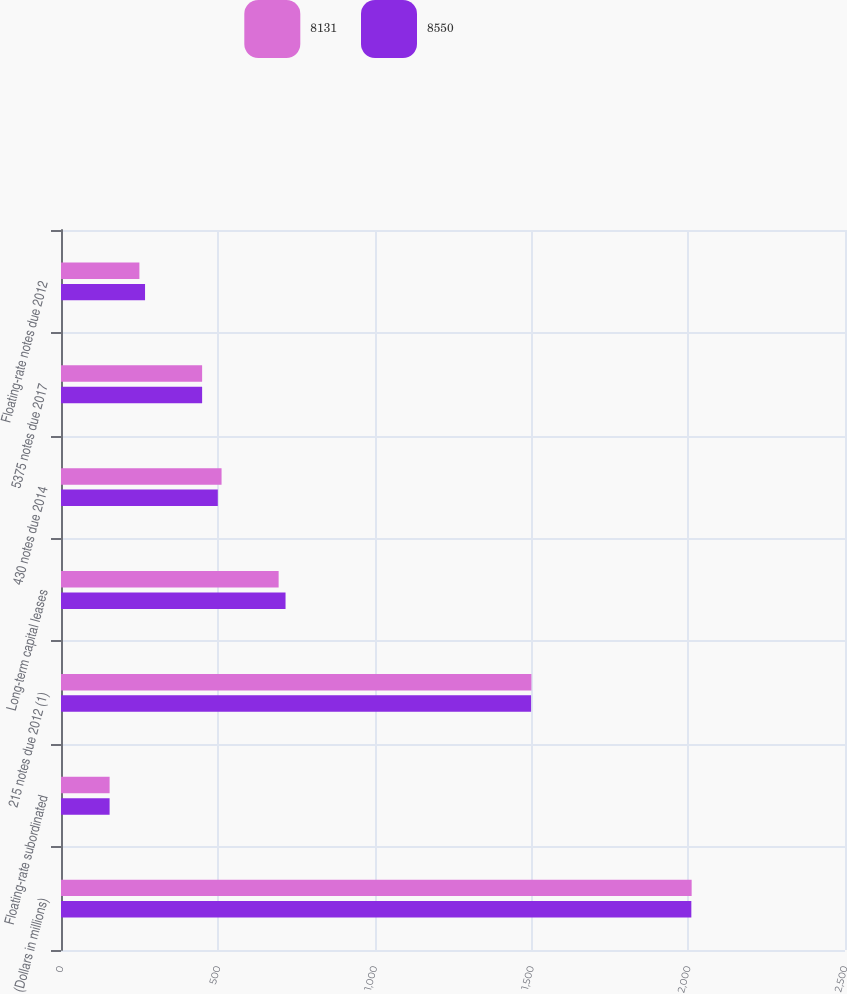<chart> <loc_0><loc_0><loc_500><loc_500><stacked_bar_chart><ecel><fcel>(Dollars in millions)<fcel>Floating-rate subordinated<fcel>215 notes due 2012 (1)<fcel>Long-term capital leases<fcel>430 notes due 2014<fcel>5375 notes due 2017<fcel>Floating-rate notes due 2012<nl><fcel>8131<fcel>2011<fcel>155<fcel>1500<fcel>694<fcel>512<fcel>450<fcel>250<nl><fcel>8550<fcel>2010<fcel>155<fcel>1499<fcel>716<fcel>500<fcel>450<fcel>268<nl></chart> 